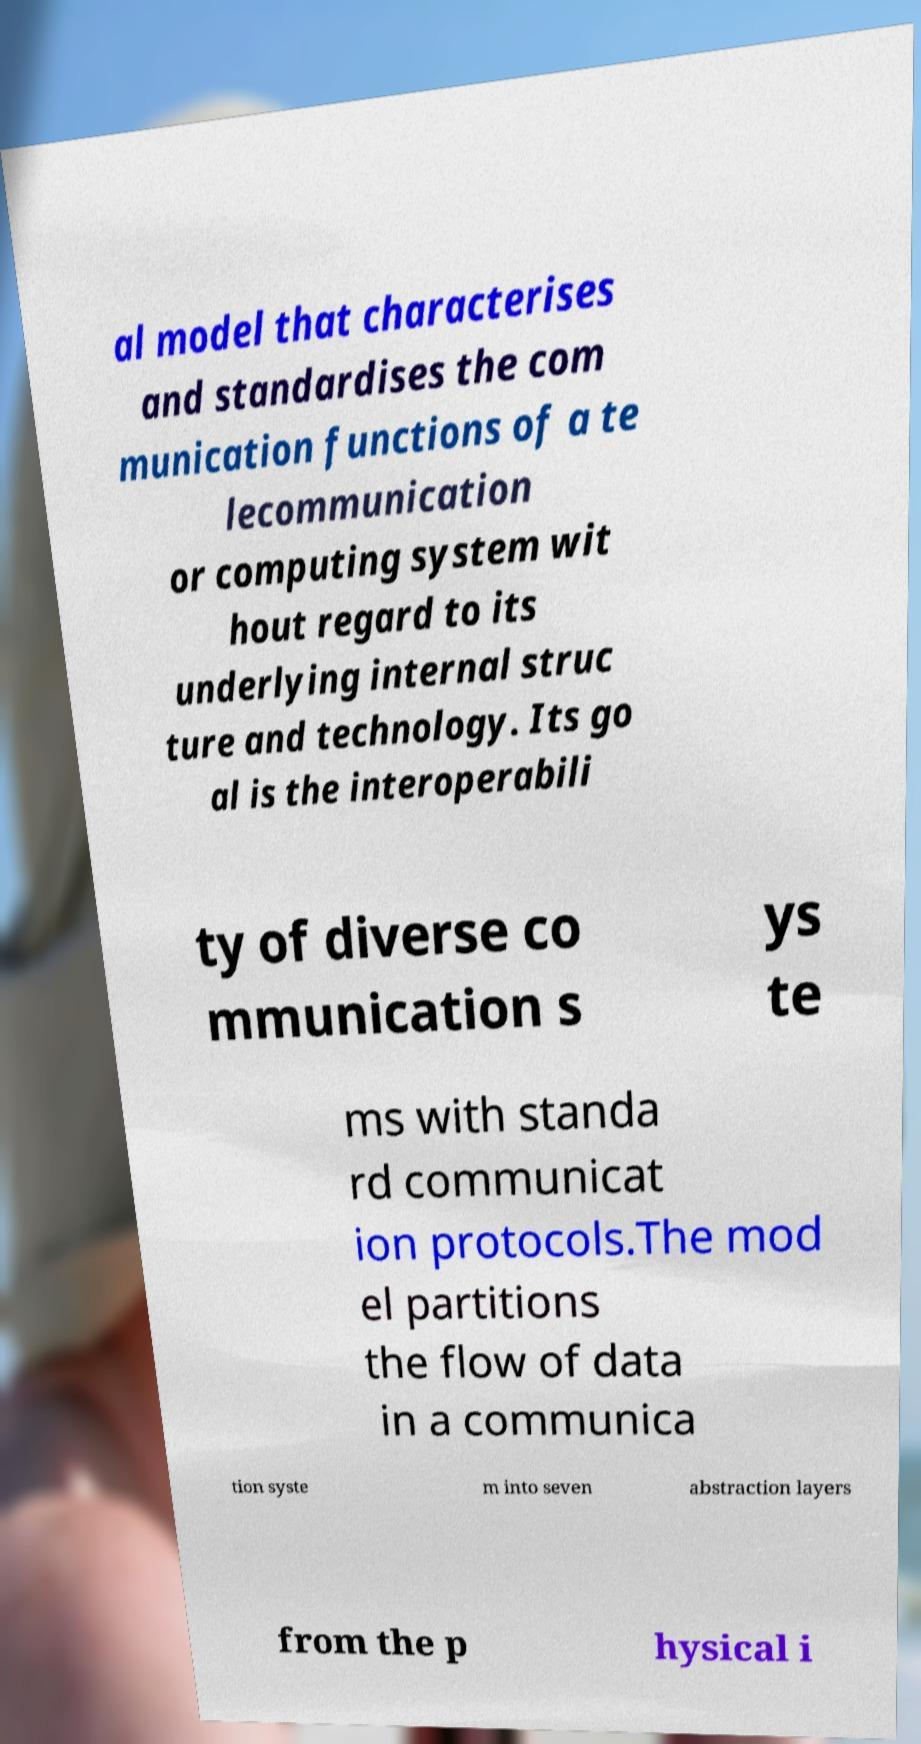What messages or text are displayed in this image? I need them in a readable, typed format. al model that characterises and standardises the com munication functions of a te lecommunication or computing system wit hout regard to its underlying internal struc ture and technology. Its go al is the interoperabili ty of diverse co mmunication s ys te ms with standa rd communicat ion protocols.The mod el partitions the flow of data in a communica tion syste m into seven abstraction layers from the p hysical i 